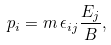Convert formula to latex. <formula><loc_0><loc_0><loc_500><loc_500>p _ { i } = m \, \epsilon _ { i j } \frac { E _ { j } } { B } ,</formula> 